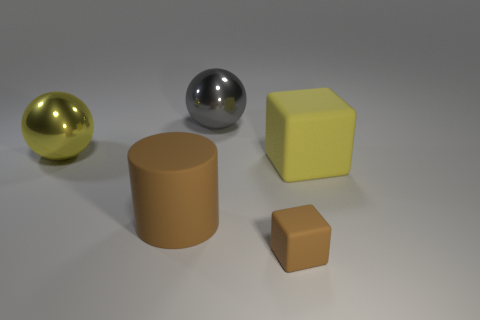Are there any other things that are the same size as the brown matte cube?
Keep it short and to the point. No. Do the sphere that is in front of the large gray metallic thing and the large thing that is behind the large yellow metal sphere have the same color?
Ensure brevity in your answer.  No. What is the shape of the yellow shiny thing that is the same size as the brown cylinder?
Give a very brief answer. Sphere. Is there a large yellow object that has the same shape as the gray shiny object?
Ensure brevity in your answer.  Yes. Is the cube behind the tiny cube made of the same material as the block in front of the brown matte cylinder?
Ensure brevity in your answer.  Yes. There is a rubber thing that is the same color as the cylinder; what shape is it?
Make the answer very short. Cube. What number of large brown objects are made of the same material as the cylinder?
Keep it short and to the point. 0. The tiny cube is what color?
Keep it short and to the point. Brown. Is the shape of the big yellow thing to the right of the yellow shiny thing the same as the big matte thing in front of the yellow matte thing?
Provide a short and direct response. No. There is a large matte object that is in front of the large yellow matte cube; what is its color?
Offer a very short reply. Brown. 